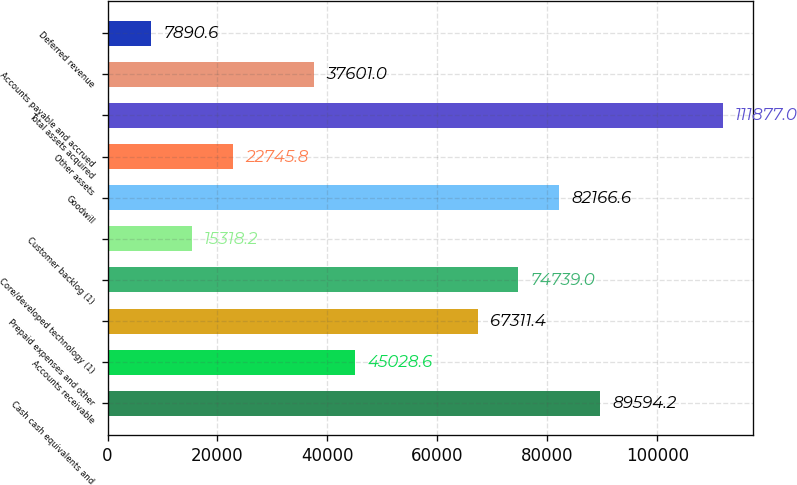<chart> <loc_0><loc_0><loc_500><loc_500><bar_chart><fcel>Cash cash equivalents and<fcel>Accounts receivable<fcel>Prepaid expenses and other<fcel>Core/developed technology (1)<fcel>Customer backlog (1)<fcel>Goodwill<fcel>Other assets<fcel>Total assets acquired<fcel>Accounts payable and accrued<fcel>Deferred revenue<nl><fcel>89594.2<fcel>45028.6<fcel>67311.4<fcel>74739<fcel>15318.2<fcel>82166.6<fcel>22745.8<fcel>111877<fcel>37601<fcel>7890.6<nl></chart> 